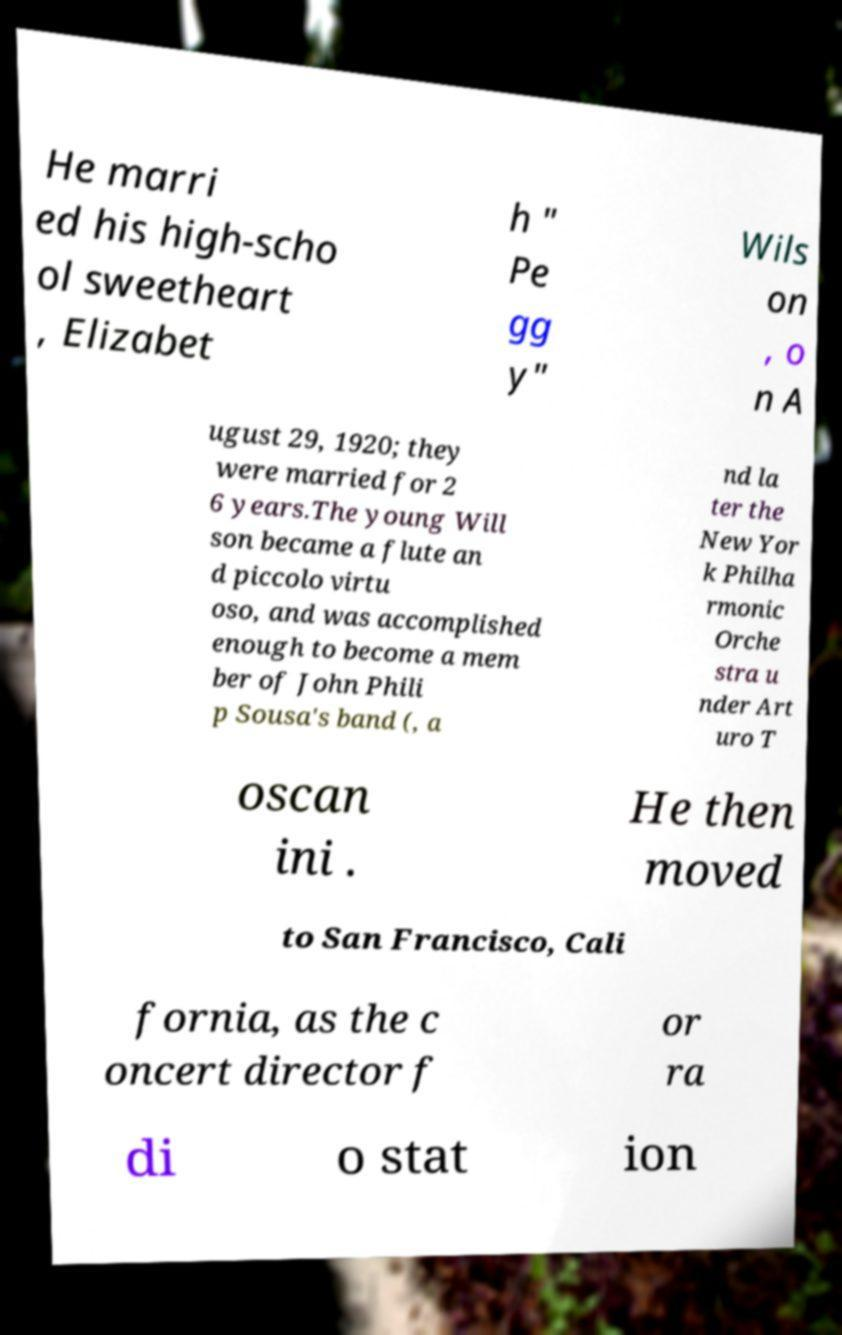Can you accurately transcribe the text from the provided image for me? He marri ed his high-scho ol sweetheart , Elizabet h " Pe gg y" Wils on , o n A ugust 29, 1920; they were married for 2 6 years.The young Will son became a flute an d piccolo virtu oso, and was accomplished enough to become a mem ber of John Phili p Sousa's band (, a nd la ter the New Yor k Philha rmonic Orche stra u nder Art uro T oscan ini . He then moved to San Francisco, Cali fornia, as the c oncert director f or ra di o stat ion 